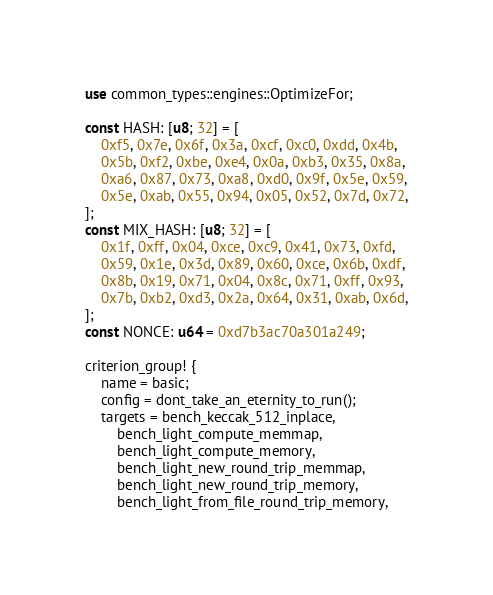<code> <loc_0><loc_0><loc_500><loc_500><_Rust_>use common_types::engines::OptimizeFor;

const HASH: [u8; 32] = [
	0xf5, 0x7e, 0x6f, 0x3a, 0xcf, 0xc0, 0xdd, 0x4b,
	0x5b, 0xf2, 0xbe, 0xe4, 0x0a, 0xb3, 0x35, 0x8a,
	0xa6, 0x87, 0x73, 0xa8, 0xd0, 0x9f, 0x5e, 0x59,
	0x5e, 0xab, 0x55, 0x94, 0x05, 0x52, 0x7d, 0x72,
];
const MIX_HASH: [u8; 32] = [
	0x1f, 0xff, 0x04, 0xce, 0xc9, 0x41, 0x73, 0xfd,
	0x59, 0x1e, 0x3d, 0x89, 0x60, 0xce, 0x6b, 0xdf,
	0x8b, 0x19, 0x71, 0x04, 0x8c, 0x71, 0xff, 0x93,
	0x7b, 0xb2, 0xd3, 0x2a, 0x64, 0x31, 0xab, 0x6d,
];
const NONCE: u64 = 0xd7b3ac70a301a249;

criterion_group! {
	name = basic;
	config = dont_take_an_eternity_to_run();
	targets = bench_keccak_512_inplace,
		bench_light_compute_memmap,
		bench_light_compute_memory,
		bench_light_new_round_trip_memmap,
		bench_light_new_round_trip_memory,
		bench_light_from_file_round_trip_memory,</code> 